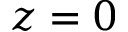Convert formula to latex. <formula><loc_0><loc_0><loc_500><loc_500>z = 0</formula> 